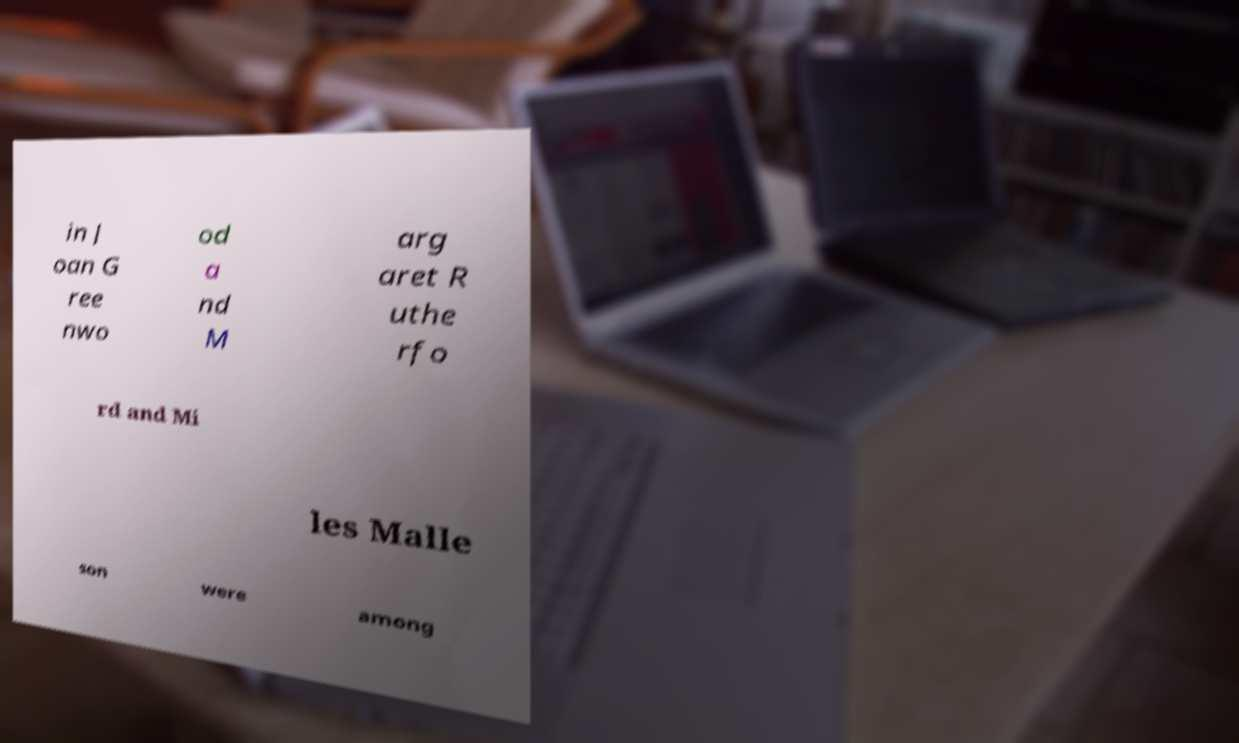What messages or text are displayed in this image? I need them in a readable, typed format. in J oan G ree nwo od a nd M arg aret R uthe rfo rd and Mi les Malle son were among 